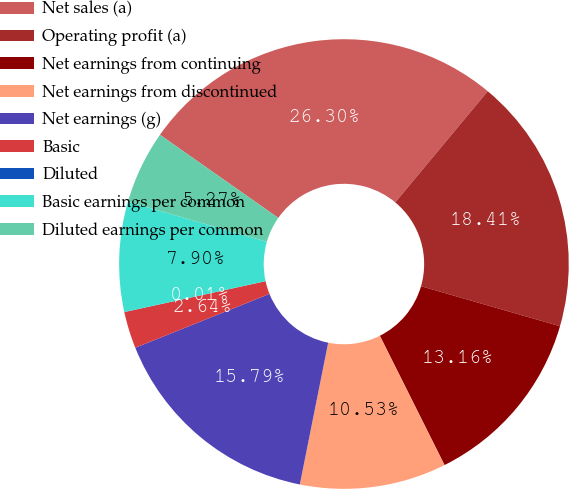<chart> <loc_0><loc_0><loc_500><loc_500><pie_chart><fcel>Net sales (a)<fcel>Operating profit (a)<fcel>Net earnings from continuing<fcel>Net earnings from discontinued<fcel>Net earnings (g)<fcel>Basic<fcel>Diluted<fcel>Basic earnings per common<fcel>Diluted earnings per common<nl><fcel>26.31%<fcel>18.42%<fcel>13.16%<fcel>10.53%<fcel>15.79%<fcel>2.64%<fcel>0.01%<fcel>7.9%<fcel>5.27%<nl></chart> 